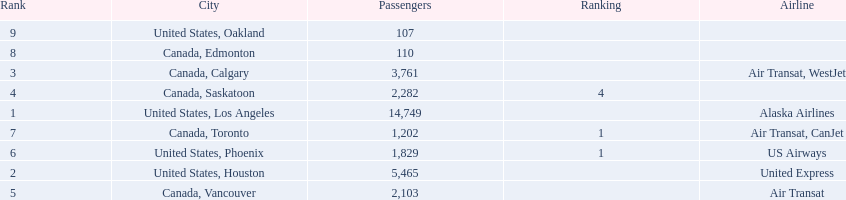Which airline carries the most passengers? Alaska Airlines. 